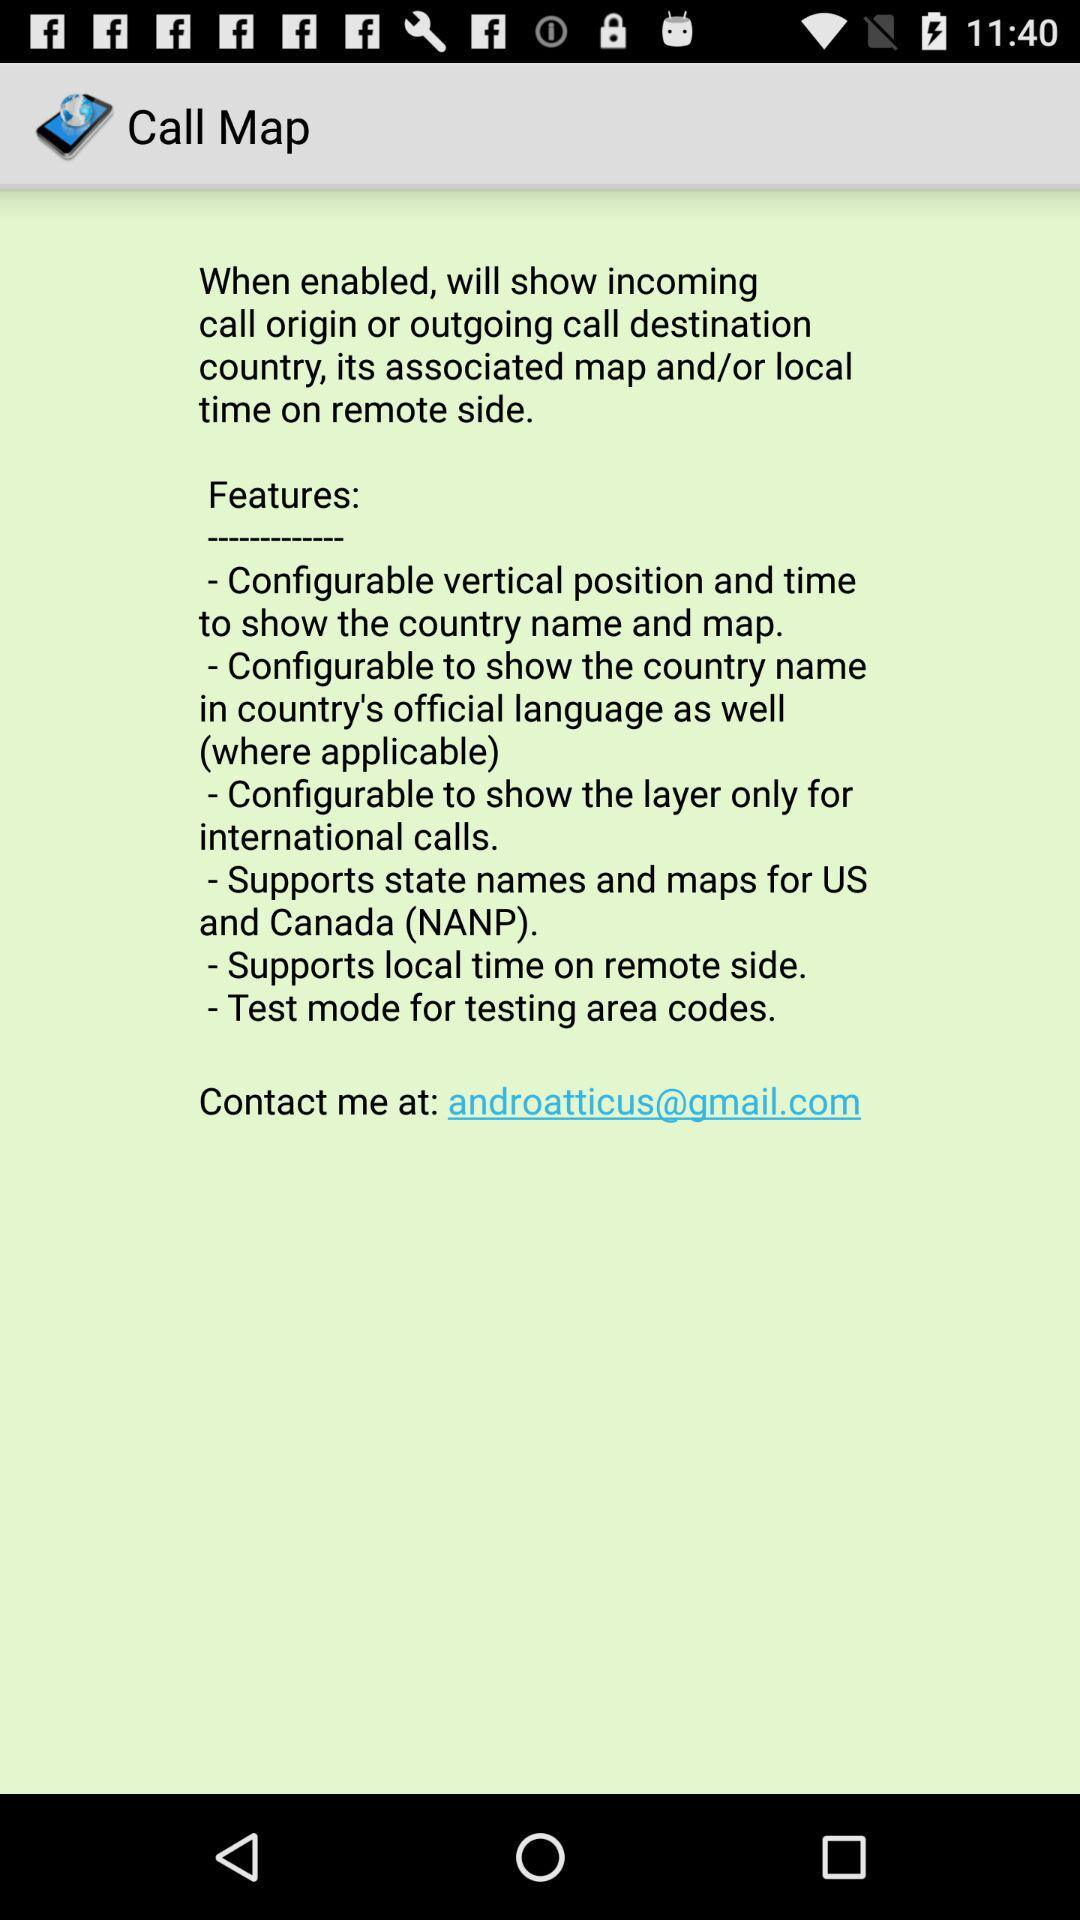What is the application name? The application name is "Call Map". 